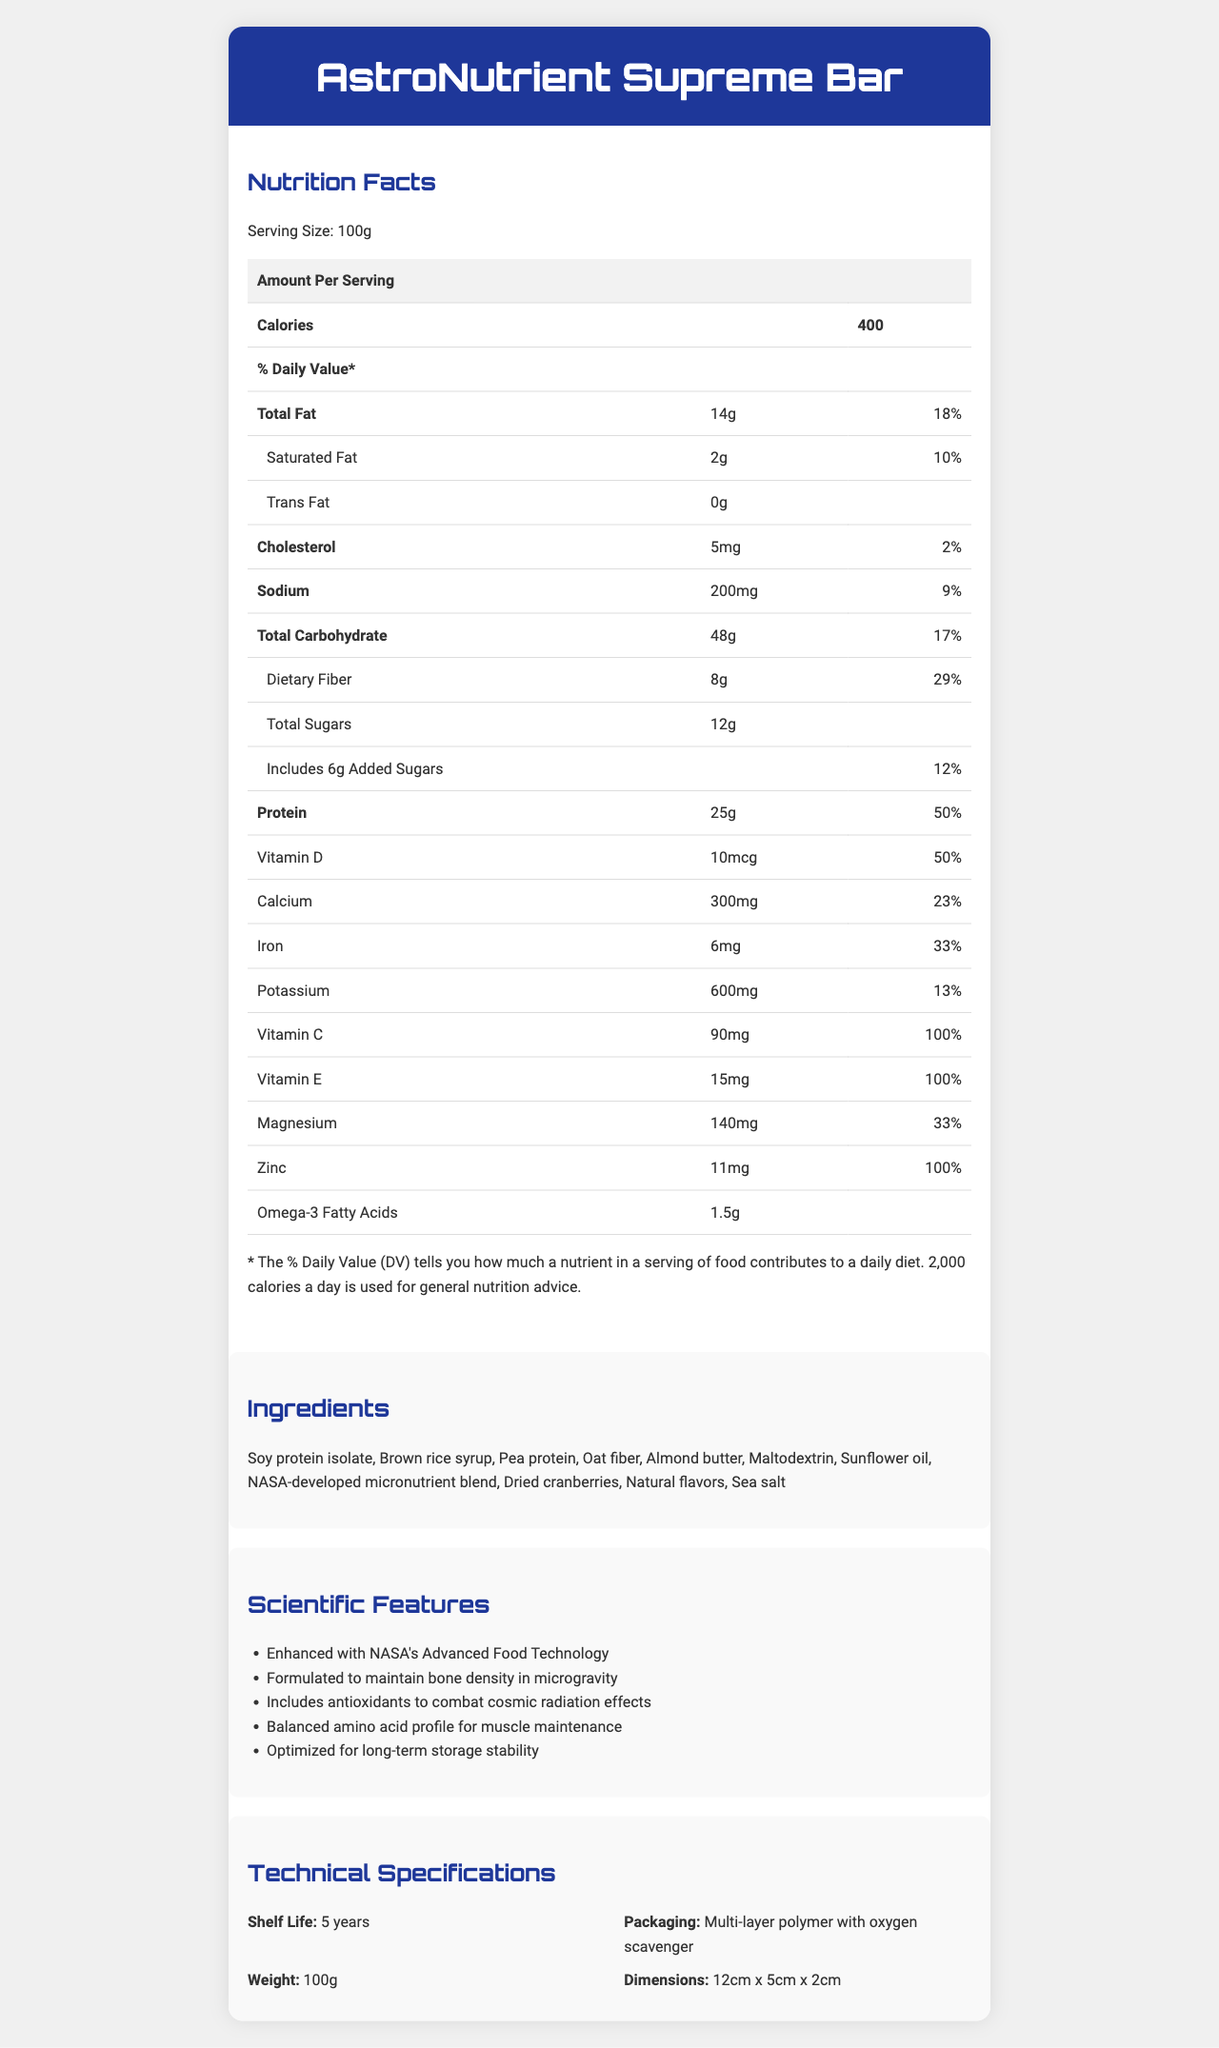What is the serving size of AstroNutrient Supreme Bar? The serving size is explicitly mentioned at the beginning of the nutrition facts: "Serving Size: 100g".
Answer: 100g How many calories are there per serving of the bar? The number of calories per serving is listed in the document: "Calories: 400".
Answer: 400 What is the total amount of fat in the bar? The total fat amount is shown under the nutrition facts: "Total Fat: 14g".
Answer: 14g How much protein is in one serving of the bar? The amount of protein per serving is listed: "Protein: 25g".
Answer: 25g What percentage of the daily value of dietary fiber does one serving provide? The daily value percentage for dietary fiber is mentioned: "Dietary Fiber: 29%".
Answer: 29% Which of the following vitamins is present in the highest amount by daily value percentage? A. Vitamin D B. Vitamin C C. Vitamin E D. Zinc Vitamin C has a daily value of 100%, which is the highest among the listed vitamins.
Answer: B How long is the shelf life of the AstroNutrient Supreme Bar? A. 1 year B. 3 years C. 5 years D. 10 years The shelf life is stated under technical specifications: "Shelf Life: 5 years".
Answer: C Does the bar contain any trans fat? The document specifies "Trans Fat: 0g", indicating no trans fat.
Answer: No Is the bar formulated to maintain bone density in microgravity? One of the scientific features lists "Formulated to maintain bone density in microgravity".
Answer: Yes Summarize the key features and nutritional benefits of the AstroNutrient Supreme Bar. This summary captures both the nutritional composition and the scientific features mentioned in the document.
Answer: The AstroNutrient Supreme Bar is a 100g meal replacement bar with 400 calories per serving. It contains 25g of protein, 14g of total fat, and 48g of carbohydrates, along with various vitamins and minerals such as Vitamin C, Vitamin E, Calcium, Iron, and Zinc. The bar is enhanced with NASA's Advanced Food Technology, formulated to maintain bone density in microgravity, and optimized for long-term storage with a shelf life of 5 years. What are the three main sources of protein in the AstroNutrient Supreme Bar? The ingredients list includes these as the main protein sources.
Answer: Soy protein isolate, Pea protein, Almond butter How much sodium does one serving of the bar contain? The sodium content is listed in the nutrition facts section: "Sodium: 200mg".
Answer: 200mg What is the intended daily value percentage for Vitamin D in the bar? The daily value percentage for Vitamin D is specified: "Vitamin D: 50%".
Answer: 50% Why can't we determine how much omega-3 fatty acids contribute to the daily value percentage? The document lists the amount of omega-3 fatty acids but does not provide a daily value percentage.
Answer: Not enough information How is the bar packaged to ensure its long-term storage? The packaging details are provided in the technical specifications.
Answer: Multi-layer polymer with oxygen scavenger 